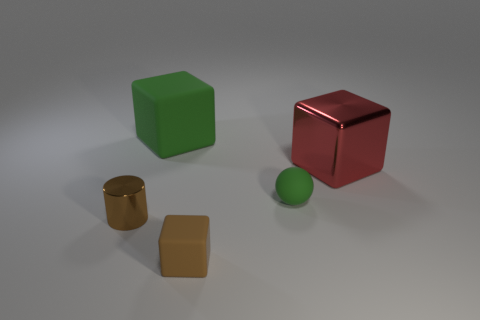Is the number of large green matte cubes in front of the brown metal cylinder the same as the number of small green things?
Ensure brevity in your answer.  No. The large cube to the left of the red cube is what color?
Offer a very short reply. Green. What number of other things are there of the same color as the tiny cylinder?
Your answer should be very brief. 1. Is there anything else that has the same size as the brown metallic cylinder?
Give a very brief answer. Yes. There is a brown object behind the brown rubber cube; is its size the same as the green matte ball?
Ensure brevity in your answer.  Yes. What is the material of the large cube that is on the right side of the small brown rubber object?
Offer a very short reply. Metal. Are there any other things that have the same shape as the big matte object?
Give a very brief answer. Yes. How many metallic objects are either small brown objects or red cubes?
Your response must be concise. 2. Is the number of small rubber things that are in front of the tiny brown cylinder less than the number of red metallic cubes?
Provide a short and direct response. No. What shape is the brown object that is to the left of the green rubber object that is on the left side of the brown object that is on the right side of the small cylinder?
Your response must be concise. Cylinder. 